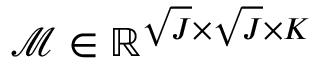<formula> <loc_0><loc_0><loc_500><loc_500>\mathcal { M } \in \mathbb { R } ^ { \sqrt { J } \times \sqrt { J } \times K }</formula> 